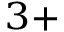Convert formula to latex. <formula><loc_0><loc_0><loc_500><loc_500>^ { 3 + }</formula> 